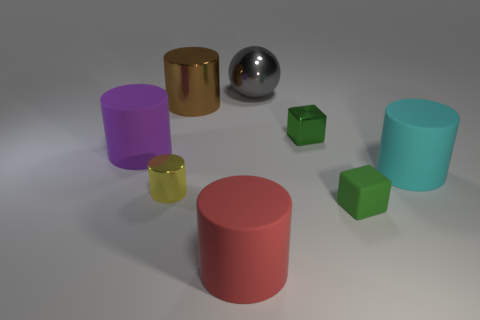What number of other things are there of the same material as the purple cylinder
Offer a terse response. 3. What is the shape of the tiny thing left of the gray shiny object?
Your response must be concise. Cylinder. There is a cylinder that is in front of the tiny object on the left side of the red matte cylinder; what is its material?
Offer a very short reply. Rubber. Are there more red cylinders on the right side of the yellow shiny cylinder than yellow objects?
Your response must be concise. No. What number of other objects are the same color as the ball?
Keep it short and to the point. 0. What shape is the red rubber object that is the same size as the purple matte cylinder?
Offer a very short reply. Cylinder. There is a large object behind the large shiny object in front of the big gray thing; how many small cylinders are in front of it?
Your answer should be very brief. 1. What number of metallic things are either tiny balls or cyan objects?
Keep it short and to the point. 0. There is a metal object that is right of the big red cylinder and in front of the big gray shiny thing; what color is it?
Your response must be concise. Green. There is a green block that is right of the green metallic cube; is it the same size as the big red rubber cylinder?
Your response must be concise. No. 